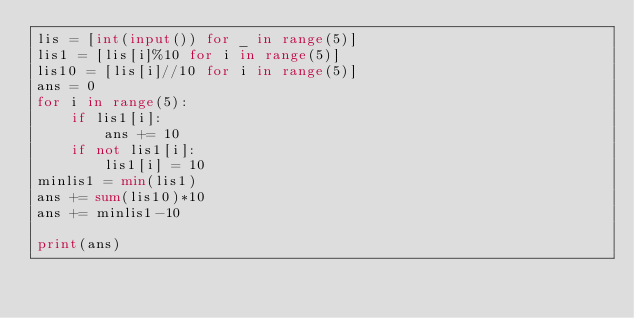<code> <loc_0><loc_0><loc_500><loc_500><_Python_>lis = [int(input()) for _ in range(5)]
lis1 = [lis[i]%10 for i in range(5)]
lis10 = [lis[i]//10 for i in range(5)]
ans = 0
for i in range(5):
    if lis1[i]:
        ans += 10
    if not lis1[i]:
        lis1[i] = 10
minlis1 = min(lis1)
ans += sum(lis10)*10
ans += minlis1-10

print(ans)</code> 